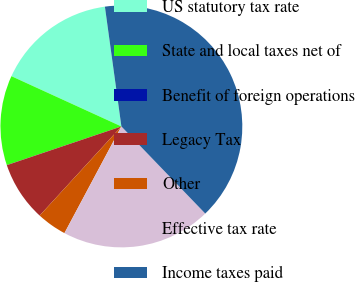Convert chart. <chart><loc_0><loc_0><loc_500><loc_500><pie_chart><fcel>US statutory tax rate<fcel>State and local taxes net of<fcel>Benefit of foreign operations<fcel>Legacy Tax<fcel>Other<fcel>Effective tax rate<fcel>Income taxes paid<nl><fcel>16.0%<fcel>12.0%<fcel>0.01%<fcel>8.0%<fcel>4.01%<fcel>20.0%<fcel>39.98%<nl></chart> 